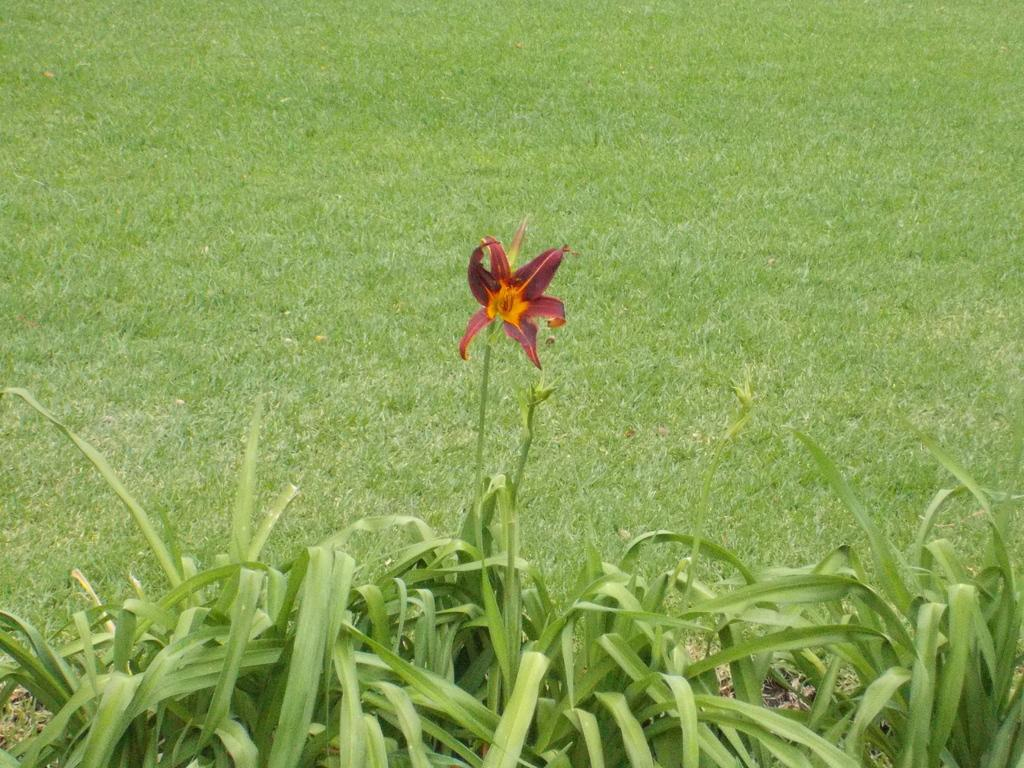What type of living organisms can be seen in the image? Plants can be seen in the image. What is the main focus of the image? There is a flower in the center of the image. What type of vegetation is visible in the background of the image? There is green grass in the background of the image. What type of jam can be seen dripping from the flower in the image? There is no jam present in the image; it is a flower surrounded by other plants. 